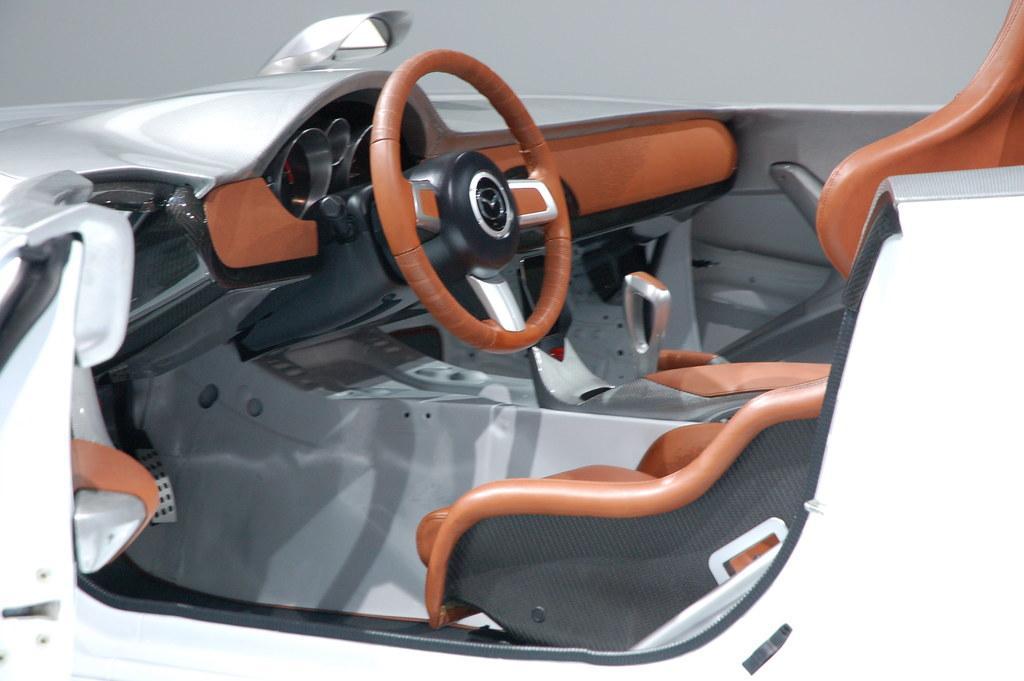In one or two sentences, can you explain what this image depicts? In this picture there is a vehicle in the white color. At the back there is cream color background. 